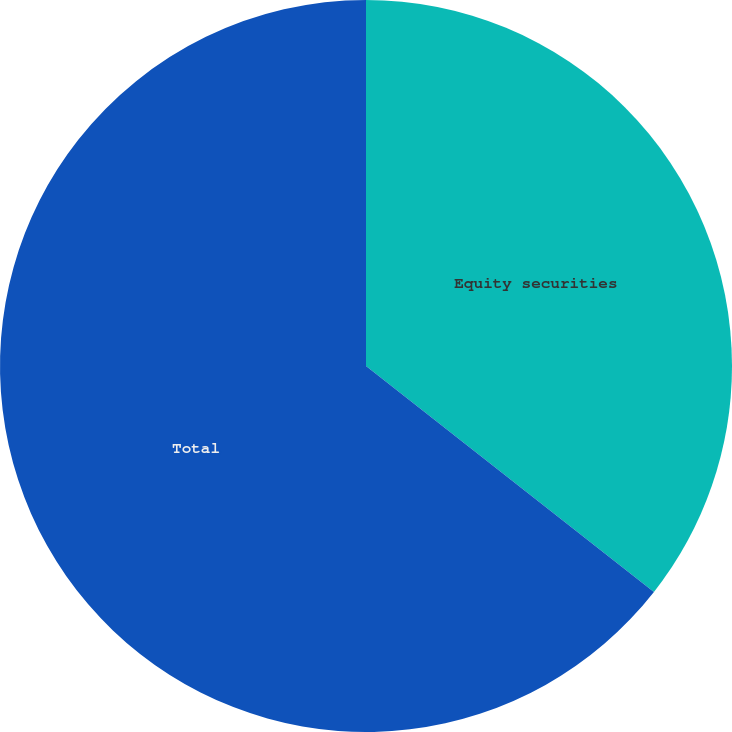<chart> <loc_0><loc_0><loc_500><loc_500><pie_chart><fcel>Equity securities<fcel>Total<nl><fcel>35.59%<fcel>64.41%<nl></chart> 